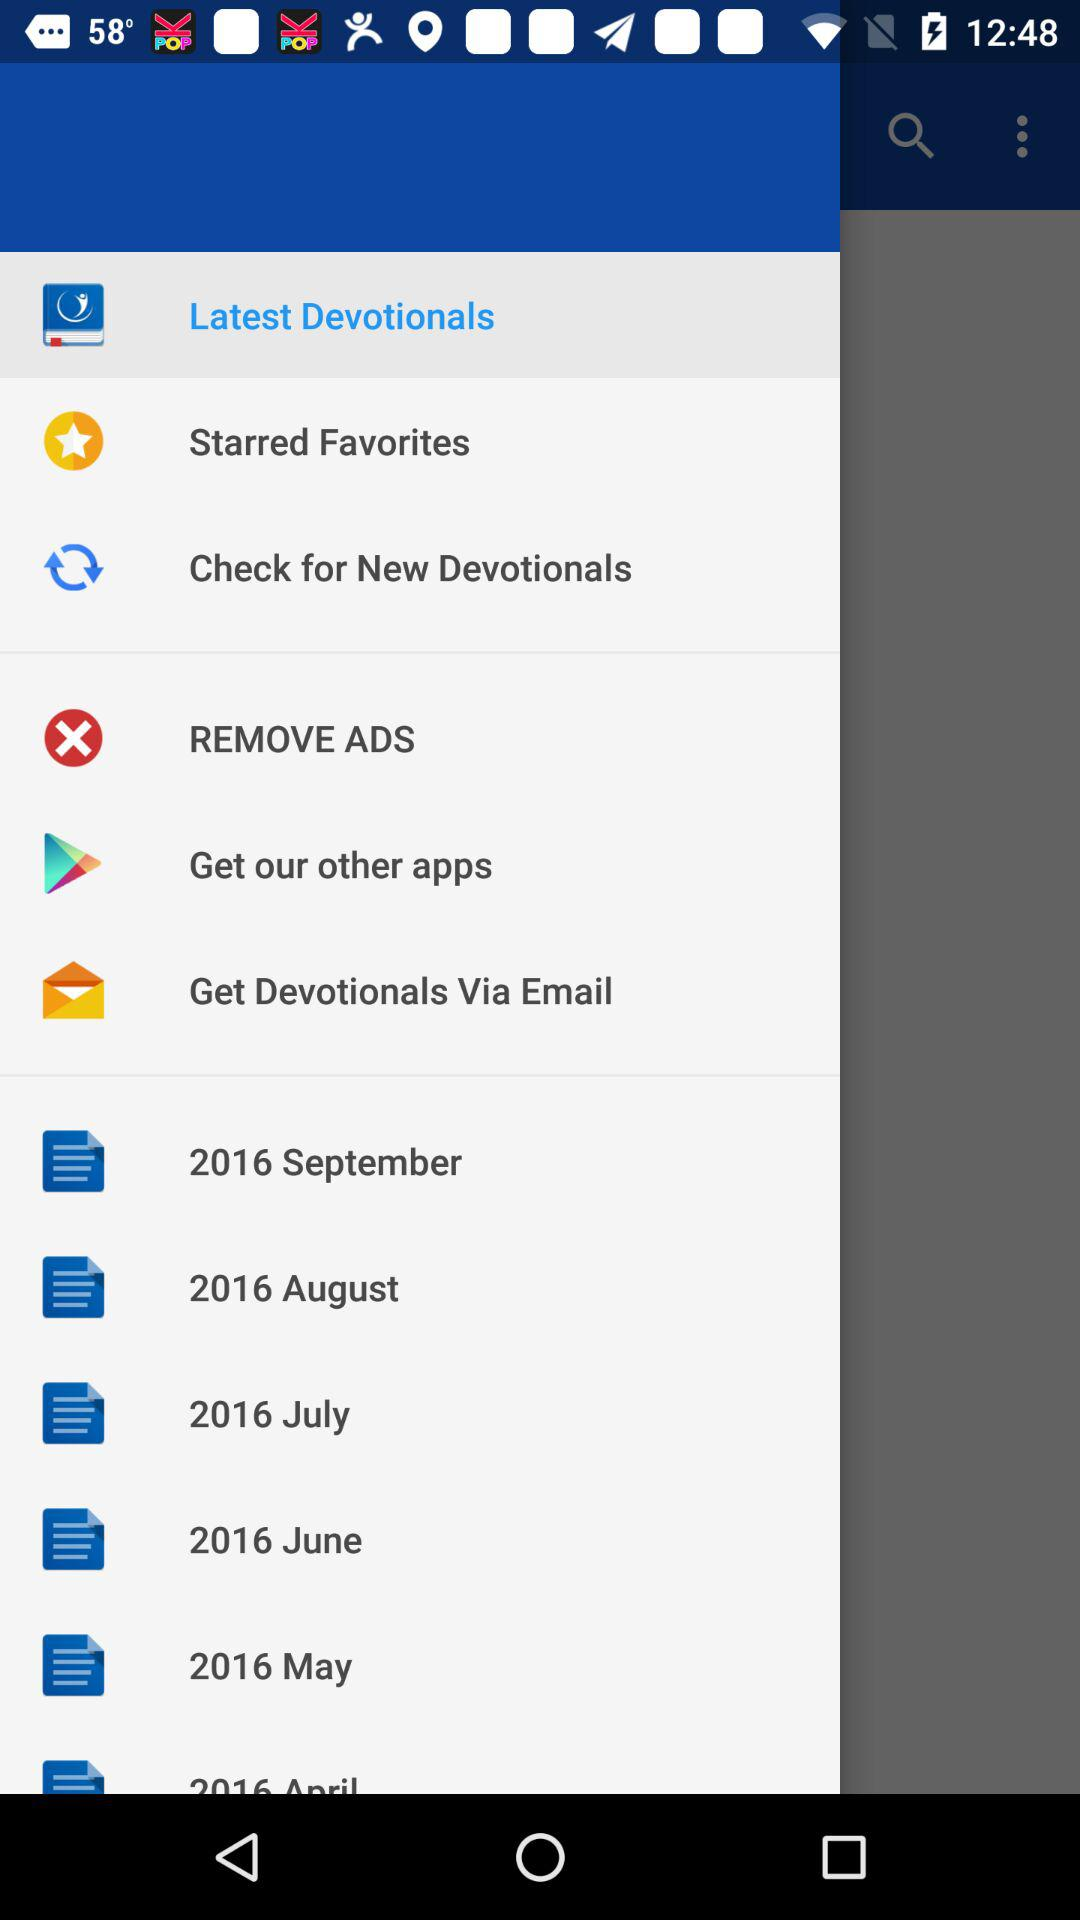Which item is selected in the menu? The item "Latest Devotionals" is selected in the menu. 